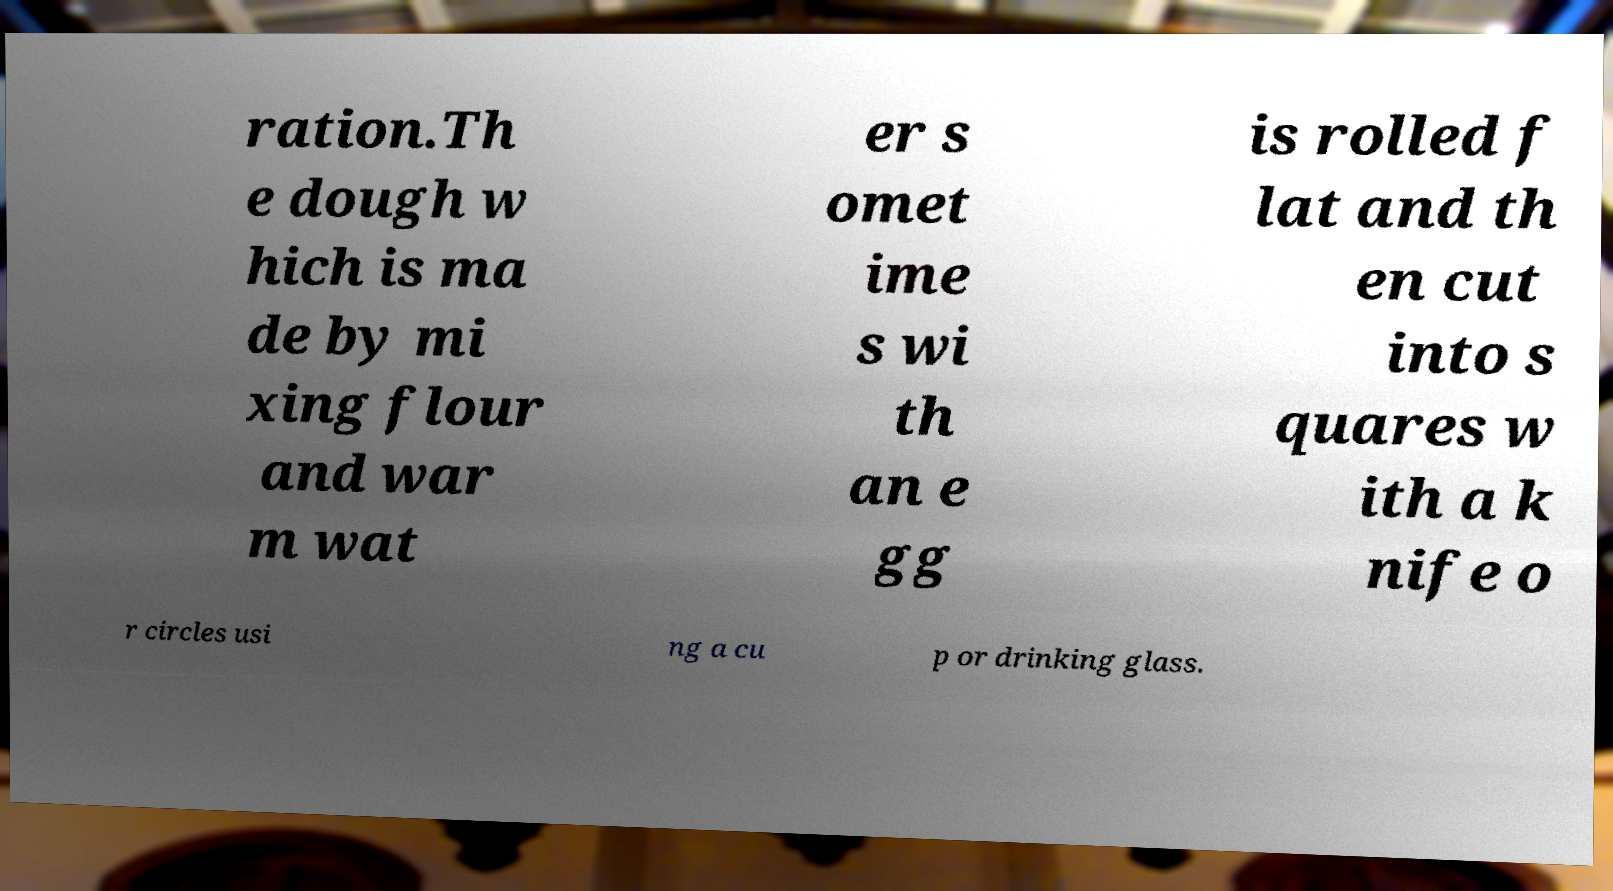What messages or text are displayed in this image? I need them in a readable, typed format. ration.Th e dough w hich is ma de by mi xing flour and war m wat er s omet ime s wi th an e gg is rolled f lat and th en cut into s quares w ith a k nife o r circles usi ng a cu p or drinking glass. 